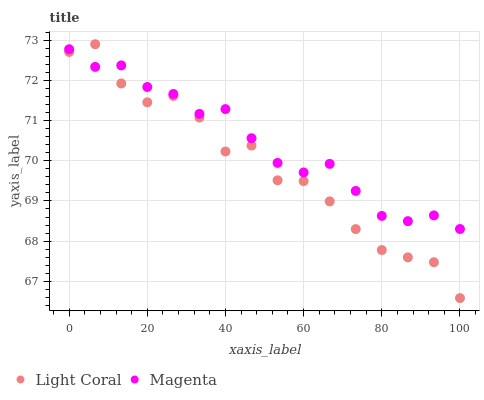Does Light Coral have the minimum area under the curve?
Answer yes or no. Yes. Does Magenta have the maximum area under the curve?
Answer yes or no. Yes. Does Magenta have the minimum area under the curve?
Answer yes or no. No. Is Magenta the smoothest?
Answer yes or no. Yes. Is Light Coral the roughest?
Answer yes or no. Yes. Is Magenta the roughest?
Answer yes or no. No. Does Light Coral have the lowest value?
Answer yes or no. Yes. Does Magenta have the lowest value?
Answer yes or no. No. Does Light Coral have the highest value?
Answer yes or no. Yes. Does Magenta have the highest value?
Answer yes or no. No. Does Light Coral intersect Magenta?
Answer yes or no. Yes. Is Light Coral less than Magenta?
Answer yes or no. No. Is Light Coral greater than Magenta?
Answer yes or no. No. 